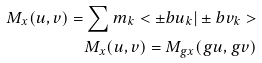<formula> <loc_0><loc_0><loc_500><loc_500>M _ { x } ( u , v ) = \sum m _ { k } < \pm b { u } _ { k } | \pm b { v } _ { k } > \\ M _ { x } ( u , v ) = M _ { g x } ( g u , g v )</formula> 